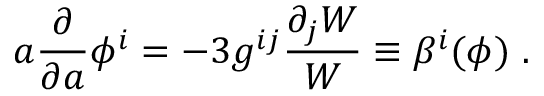Convert formula to latex. <formula><loc_0><loc_0><loc_500><loc_500>a { \frac { \partial } { \partial a } } \phi ^ { i } = - 3 g ^ { i j } { \frac { \partial _ { j } W } { W } } \equiv \beta ^ { i } ( \phi ) \ .</formula> 